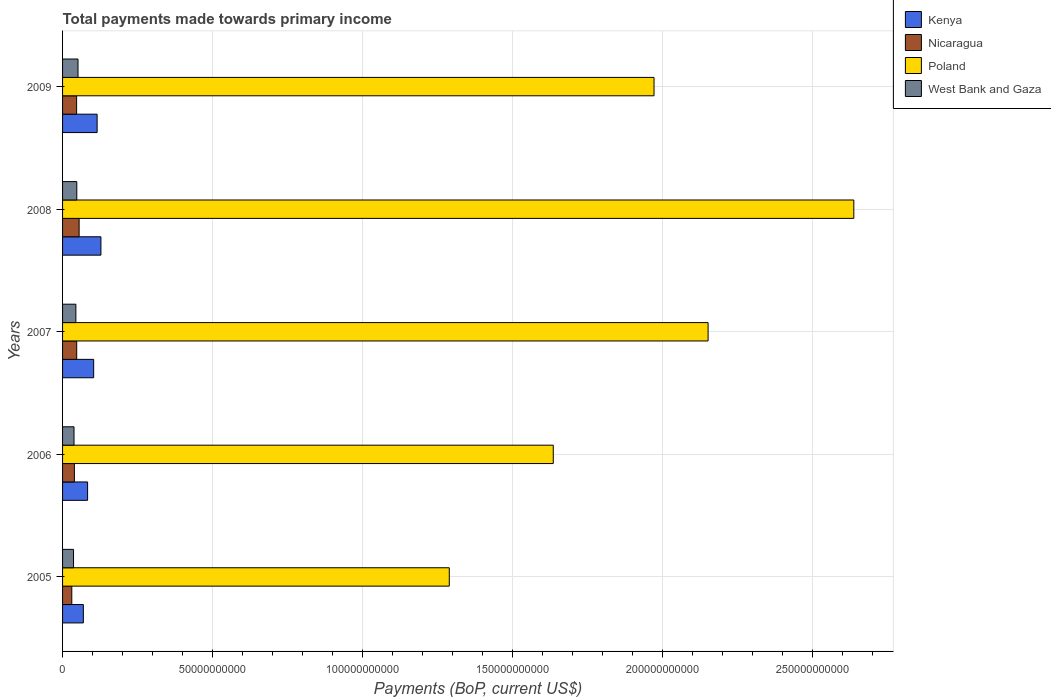How many different coloured bars are there?
Your response must be concise. 4. How many groups of bars are there?
Your response must be concise. 5. Are the number of bars on each tick of the Y-axis equal?
Keep it short and to the point. Yes. In how many cases, is the number of bars for a given year not equal to the number of legend labels?
Keep it short and to the point. 0. What is the total payments made towards primary income in Nicaragua in 2008?
Provide a succinct answer. 5.52e+09. Across all years, what is the maximum total payments made towards primary income in Poland?
Your answer should be very brief. 2.64e+11. Across all years, what is the minimum total payments made towards primary income in Kenya?
Your answer should be compact. 6.92e+09. In which year was the total payments made towards primary income in West Bank and Gaza maximum?
Ensure brevity in your answer.  2009. In which year was the total payments made towards primary income in West Bank and Gaza minimum?
Ensure brevity in your answer.  2005. What is the total total payments made towards primary income in West Bank and Gaza in the graph?
Keep it short and to the point. 2.18e+1. What is the difference between the total payments made towards primary income in West Bank and Gaza in 2007 and that in 2008?
Offer a terse response. -3.10e+08. What is the difference between the total payments made towards primary income in Kenya in 2006 and the total payments made towards primary income in Poland in 2008?
Provide a succinct answer. -2.55e+11. What is the average total payments made towards primary income in Nicaragua per year?
Your response must be concise. 4.39e+09. In the year 2009, what is the difference between the total payments made towards primary income in Kenya and total payments made towards primary income in Poland?
Your response must be concise. -1.86e+11. What is the ratio of the total payments made towards primary income in Poland in 2005 to that in 2009?
Make the answer very short. 0.65. What is the difference between the highest and the second highest total payments made towards primary income in West Bank and Gaza?
Your answer should be compact. 4.04e+08. What is the difference between the highest and the lowest total payments made towards primary income in Kenya?
Provide a short and direct response. 5.86e+09. In how many years, is the total payments made towards primary income in Nicaragua greater than the average total payments made towards primary income in Nicaragua taken over all years?
Your answer should be compact. 3. What does the 4th bar from the top in 2007 represents?
Give a very brief answer. Kenya. What does the 4th bar from the bottom in 2005 represents?
Offer a very short reply. West Bank and Gaza. Is it the case that in every year, the sum of the total payments made towards primary income in Poland and total payments made towards primary income in Nicaragua is greater than the total payments made towards primary income in West Bank and Gaza?
Make the answer very short. Yes. Are all the bars in the graph horizontal?
Give a very brief answer. Yes. Are the values on the major ticks of X-axis written in scientific E-notation?
Offer a terse response. No. Does the graph contain grids?
Your response must be concise. Yes. How many legend labels are there?
Your answer should be very brief. 4. How are the legend labels stacked?
Your answer should be very brief. Vertical. What is the title of the graph?
Offer a very short reply. Total payments made towards primary income. Does "Saudi Arabia" appear as one of the legend labels in the graph?
Ensure brevity in your answer.  No. What is the label or title of the X-axis?
Offer a very short reply. Payments (BoP, current US$). What is the Payments (BoP, current US$) of Kenya in 2005?
Your answer should be compact. 6.92e+09. What is the Payments (BoP, current US$) in Nicaragua in 2005?
Make the answer very short. 3.07e+09. What is the Payments (BoP, current US$) of Poland in 2005?
Offer a terse response. 1.29e+11. What is the Payments (BoP, current US$) of West Bank and Gaza in 2005?
Offer a terse response. 3.65e+09. What is the Payments (BoP, current US$) of Kenya in 2006?
Provide a succinct answer. 8.34e+09. What is the Payments (BoP, current US$) of Nicaragua in 2006?
Offer a terse response. 3.94e+09. What is the Payments (BoP, current US$) in Poland in 2006?
Your response must be concise. 1.63e+11. What is the Payments (BoP, current US$) of West Bank and Gaza in 2006?
Offer a very short reply. 3.81e+09. What is the Payments (BoP, current US$) of Kenya in 2007?
Provide a succinct answer. 1.04e+1. What is the Payments (BoP, current US$) of Nicaragua in 2007?
Your response must be concise. 4.71e+09. What is the Payments (BoP, current US$) in Poland in 2007?
Keep it short and to the point. 2.15e+11. What is the Payments (BoP, current US$) in West Bank and Gaza in 2007?
Keep it short and to the point. 4.43e+09. What is the Payments (BoP, current US$) of Kenya in 2008?
Offer a very short reply. 1.28e+1. What is the Payments (BoP, current US$) in Nicaragua in 2008?
Make the answer very short. 5.52e+09. What is the Payments (BoP, current US$) in Poland in 2008?
Offer a very short reply. 2.64e+11. What is the Payments (BoP, current US$) in West Bank and Gaza in 2008?
Your response must be concise. 4.74e+09. What is the Payments (BoP, current US$) in Kenya in 2009?
Your answer should be compact. 1.15e+1. What is the Payments (BoP, current US$) of Nicaragua in 2009?
Provide a short and direct response. 4.68e+09. What is the Payments (BoP, current US$) of Poland in 2009?
Offer a terse response. 1.97e+11. What is the Payments (BoP, current US$) of West Bank and Gaza in 2009?
Your answer should be very brief. 5.15e+09. Across all years, what is the maximum Payments (BoP, current US$) of Kenya?
Your response must be concise. 1.28e+1. Across all years, what is the maximum Payments (BoP, current US$) in Nicaragua?
Give a very brief answer. 5.52e+09. Across all years, what is the maximum Payments (BoP, current US$) in Poland?
Give a very brief answer. 2.64e+11. Across all years, what is the maximum Payments (BoP, current US$) of West Bank and Gaza?
Make the answer very short. 5.15e+09. Across all years, what is the minimum Payments (BoP, current US$) of Kenya?
Offer a very short reply. 6.92e+09. Across all years, what is the minimum Payments (BoP, current US$) of Nicaragua?
Provide a short and direct response. 3.07e+09. Across all years, what is the minimum Payments (BoP, current US$) of Poland?
Make the answer very short. 1.29e+11. Across all years, what is the minimum Payments (BoP, current US$) in West Bank and Gaza?
Provide a short and direct response. 3.65e+09. What is the total Payments (BoP, current US$) in Kenya in the graph?
Your response must be concise. 4.99e+1. What is the total Payments (BoP, current US$) of Nicaragua in the graph?
Make the answer very short. 2.19e+1. What is the total Payments (BoP, current US$) of Poland in the graph?
Provide a succinct answer. 9.68e+11. What is the total Payments (BoP, current US$) in West Bank and Gaza in the graph?
Your answer should be very brief. 2.18e+1. What is the difference between the Payments (BoP, current US$) in Kenya in 2005 and that in 2006?
Your answer should be very brief. -1.42e+09. What is the difference between the Payments (BoP, current US$) of Nicaragua in 2005 and that in 2006?
Give a very brief answer. -8.67e+08. What is the difference between the Payments (BoP, current US$) of Poland in 2005 and that in 2006?
Give a very brief answer. -3.46e+1. What is the difference between the Payments (BoP, current US$) of West Bank and Gaza in 2005 and that in 2006?
Make the answer very short. -1.61e+08. What is the difference between the Payments (BoP, current US$) of Kenya in 2005 and that in 2007?
Your answer should be very brief. -3.44e+09. What is the difference between the Payments (BoP, current US$) of Nicaragua in 2005 and that in 2007?
Your answer should be compact. -1.64e+09. What is the difference between the Payments (BoP, current US$) of Poland in 2005 and that in 2007?
Ensure brevity in your answer.  -8.62e+1. What is the difference between the Payments (BoP, current US$) of West Bank and Gaza in 2005 and that in 2007?
Ensure brevity in your answer.  -7.79e+08. What is the difference between the Payments (BoP, current US$) of Kenya in 2005 and that in 2008?
Provide a short and direct response. -5.86e+09. What is the difference between the Payments (BoP, current US$) of Nicaragua in 2005 and that in 2008?
Ensure brevity in your answer.  -2.44e+09. What is the difference between the Payments (BoP, current US$) of Poland in 2005 and that in 2008?
Offer a terse response. -1.35e+11. What is the difference between the Payments (BoP, current US$) in West Bank and Gaza in 2005 and that in 2008?
Make the answer very short. -1.09e+09. What is the difference between the Payments (BoP, current US$) in Kenya in 2005 and that in 2009?
Your response must be concise. -4.59e+09. What is the difference between the Payments (BoP, current US$) in Nicaragua in 2005 and that in 2009?
Ensure brevity in your answer.  -1.61e+09. What is the difference between the Payments (BoP, current US$) of Poland in 2005 and that in 2009?
Ensure brevity in your answer.  -6.82e+1. What is the difference between the Payments (BoP, current US$) of West Bank and Gaza in 2005 and that in 2009?
Offer a terse response. -1.49e+09. What is the difference between the Payments (BoP, current US$) in Kenya in 2006 and that in 2007?
Give a very brief answer. -2.02e+09. What is the difference between the Payments (BoP, current US$) of Nicaragua in 2006 and that in 2007?
Provide a succinct answer. -7.70e+08. What is the difference between the Payments (BoP, current US$) in Poland in 2006 and that in 2007?
Offer a terse response. -5.16e+1. What is the difference between the Payments (BoP, current US$) in West Bank and Gaza in 2006 and that in 2007?
Make the answer very short. -6.18e+08. What is the difference between the Payments (BoP, current US$) of Kenya in 2006 and that in 2008?
Give a very brief answer. -4.44e+09. What is the difference between the Payments (BoP, current US$) in Nicaragua in 2006 and that in 2008?
Your response must be concise. -1.58e+09. What is the difference between the Payments (BoP, current US$) of Poland in 2006 and that in 2008?
Your response must be concise. -1.00e+11. What is the difference between the Payments (BoP, current US$) in West Bank and Gaza in 2006 and that in 2008?
Your response must be concise. -9.28e+08. What is the difference between the Payments (BoP, current US$) of Kenya in 2006 and that in 2009?
Your answer should be compact. -3.17e+09. What is the difference between the Payments (BoP, current US$) in Nicaragua in 2006 and that in 2009?
Give a very brief answer. -7.39e+08. What is the difference between the Payments (BoP, current US$) in Poland in 2006 and that in 2009?
Provide a succinct answer. -3.36e+1. What is the difference between the Payments (BoP, current US$) of West Bank and Gaza in 2006 and that in 2009?
Provide a short and direct response. -1.33e+09. What is the difference between the Payments (BoP, current US$) of Kenya in 2007 and that in 2008?
Provide a succinct answer. -2.42e+09. What is the difference between the Payments (BoP, current US$) in Nicaragua in 2007 and that in 2008?
Offer a very short reply. -8.07e+08. What is the difference between the Payments (BoP, current US$) in Poland in 2007 and that in 2008?
Offer a terse response. -4.86e+1. What is the difference between the Payments (BoP, current US$) of West Bank and Gaza in 2007 and that in 2008?
Offer a terse response. -3.10e+08. What is the difference between the Payments (BoP, current US$) of Kenya in 2007 and that in 2009?
Offer a terse response. -1.15e+09. What is the difference between the Payments (BoP, current US$) of Nicaragua in 2007 and that in 2009?
Offer a terse response. 3.12e+07. What is the difference between the Payments (BoP, current US$) of Poland in 2007 and that in 2009?
Offer a very short reply. 1.80e+1. What is the difference between the Payments (BoP, current US$) of West Bank and Gaza in 2007 and that in 2009?
Provide a short and direct response. -7.14e+08. What is the difference between the Payments (BoP, current US$) in Kenya in 2008 and that in 2009?
Offer a terse response. 1.27e+09. What is the difference between the Payments (BoP, current US$) of Nicaragua in 2008 and that in 2009?
Offer a very short reply. 8.38e+08. What is the difference between the Payments (BoP, current US$) in Poland in 2008 and that in 2009?
Ensure brevity in your answer.  6.66e+1. What is the difference between the Payments (BoP, current US$) of West Bank and Gaza in 2008 and that in 2009?
Your answer should be compact. -4.04e+08. What is the difference between the Payments (BoP, current US$) in Kenya in 2005 and the Payments (BoP, current US$) in Nicaragua in 2006?
Ensure brevity in your answer.  2.98e+09. What is the difference between the Payments (BoP, current US$) in Kenya in 2005 and the Payments (BoP, current US$) in Poland in 2006?
Your answer should be very brief. -1.57e+11. What is the difference between the Payments (BoP, current US$) in Kenya in 2005 and the Payments (BoP, current US$) in West Bank and Gaza in 2006?
Your answer should be very brief. 3.11e+09. What is the difference between the Payments (BoP, current US$) in Nicaragua in 2005 and the Payments (BoP, current US$) in Poland in 2006?
Your answer should be very brief. -1.60e+11. What is the difference between the Payments (BoP, current US$) of Nicaragua in 2005 and the Payments (BoP, current US$) of West Bank and Gaza in 2006?
Give a very brief answer. -7.39e+08. What is the difference between the Payments (BoP, current US$) of Poland in 2005 and the Payments (BoP, current US$) of West Bank and Gaza in 2006?
Provide a succinct answer. 1.25e+11. What is the difference between the Payments (BoP, current US$) in Kenya in 2005 and the Payments (BoP, current US$) in Nicaragua in 2007?
Offer a terse response. 2.21e+09. What is the difference between the Payments (BoP, current US$) of Kenya in 2005 and the Payments (BoP, current US$) of Poland in 2007?
Your answer should be very brief. -2.08e+11. What is the difference between the Payments (BoP, current US$) of Kenya in 2005 and the Payments (BoP, current US$) of West Bank and Gaza in 2007?
Provide a succinct answer. 2.49e+09. What is the difference between the Payments (BoP, current US$) in Nicaragua in 2005 and the Payments (BoP, current US$) in Poland in 2007?
Provide a succinct answer. -2.12e+11. What is the difference between the Payments (BoP, current US$) in Nicaragua in 2005 and the Payments (BoP, current US$) in West Bank and Gaza in 2007?
Provide a succinct answer. -1.36e+09. What is the difference between the Payments (BoP, current US$) of Poland in 2005 and the Payments (BoP, current US$) of West Bank and Gaza in 2007?
Your response must be concise. 1.24e+11. What is the difference between the Payments (BoP, current US$) in Kenya in 2005 and the Payments (BoP, current US$) in Nicaragua in 2008?
Keep it short and to the point. 1.40e+09. What is the difference between the Payments (BoP, current US$) in Kenya in 2005 and the Payments (BoP, current US$) in Poland in 2008?
Provide a short and direct response. -2.57e+11. What is the difference between the Payments (BoP, current US$) in Kenya in 2005 and the Payments (BoP, current US$) in West Bank and Gaza in 2008?
Offer a terse response. 2.18e+09. What is the difference between the Payments (BoP, current US$) in Nicaragua in 2005 and the Payments (BoP, current US$) in Poland in 2008?
Provide a succinct answer. -2.61e+11. What is the difference between the Payments (BoP, current US$) in Nicaragua in 2005 and the Payments (BoP, current US$) in West Bank and Gaza in 2008?
Your answer should be compact. -1.67e+09. What is the difference between the Payments (BoP, current US$) of Poland in 2005 and the Payments (BoP, current US$) of West Bank and Gaza in 2008?
Your answer should be very brief. 1.24e+11. What is the difference between the Payments (BoP, current US$) of Kenya in 2005 and the Payments (BoP, current US$) of Nicaragua in 2009?
Make the answer very short. 2.24e+09. What is the difference between the Payments (BoP, current US$) of Kenya in 2005 and the Payments (BoP, current US$) of Poland in 2009?
Keep it short and to the point. -1.90e+11. What is the difference between the Payments (BoP, current US$) of Kenya in 2005 and the Payments (BoP, current US$) of West Bank and Gaza in 2009?
Ensure brevity in your answer.  1.77e+09. What is the difference between the Payments (BoP, current US$) in Nicaragua in 2005 and the Payments (BoP, current US$) in Poland in 2009?
Offer a terse response. -1.94e+11. What is the difference between the Payments (BoP, current US$) in Nicaragua in 2005 and the Payments (BoP, current US$) in West Bank and Gaza in 2009?
Your response must be concise. -2.07e+09. What is the difference between the Payments (BoP, current US$) in Poland in 2005 and the Payments (BoP, current US$) in West Bank and Gaza in 2009?
Your answer should be compact. 1.24e+11. What is the difference between the Payments (BoP, current US$) of Kenya in 2006 and the Payments (BoP, current US$) of Nicaragua in 2007?
Provide a succinct answer. 3.63e+09. What is the difference between the Payments (BoP, current US$) of Kenya in 2006 and the Payments (BoP, current US$) of Poland in 2007?
Offer a very short reply. -2.07e+11. What is the difference between the Payments (BoP, current US$) of Kenya in 2006 and the Payments (BoP, current US$) of West Bank and Gaza in 2007?
Keep it short and to the point. 3.91e+09. What is the difference between the Payments (BoP, current US$) of Nicaragua in 2006 and the Payments (BoP, current US$) of Poland in 2007?
Ensure brevity in your answer.  -2.11e+11. What is the difference between the Payments (BoP, current US$) of Nicaragua in 2006 and the Payments (BoP, current US$) of West Bank and Gaza in 2007?
Offer a very short reply. -4.90e+08. What is the difference between the Payments (BoP, current US$) of Poland in 2006 and the Payments (BoP, current US$) of West Bank and Gaza in 2007?
Provide a succinct answer. 1.59e+11. What is the difference between the Payments (BoP, current US$) in Kenya in 2006 and the Payments (BoP, current US$) in Nicaragua in 2008?
Ensure brevity in your answer.  2.82e+09. What is the difference between the Payments (BoP, current US$) of Kenya in 2006 and the Payments (BoP, current US$) of Poland in 2008?
Provide a short and direct response. -2.55e+11. What is the difference between the Payments (BoP, current US$) of Kenya in 2006 and the Payments (BoP, current US$) of West Bank and Gaza in 2008?
Your answer should be very brief. 3.60e+09. What is the difference between the Payments (BoP, current US$) of Nicaragua in 2006 and the Payments (BoP, current US$) of Poland in 2008?
Your response must be concise. -2.60e+11. What is the difference between the Payments (BoP, current US$) of Nicaragua in 2006 and the Payments (BoP, current US$) of West Bank and Gaza in 2008?
Your answer should be compact. -8.00e+08. What is the difference between the Payments (BoP, current US$) in Poland in 2006 and the Payments (BoP, current US$) in West Bank and Gaza in 2008?
Provide a succinct answer. 1.59e+11. What is the difference between the Payments (BoP, current US$) of Kenya in 2006 and the Payments (BoP, current US$) of Nicaragua in 2009?
Provide a succinct answer. 3.66e+09. What is the difference between the Payments (BoP, current US$) of Kenya in 2006 and the Payments (BoP, current US$) of Poland in 2009?
Offer a very short reply. -1.89e+11. What is the difference between the Payments (BoP, current US$) of Kenya in 2006 and the Payments (BoP, current US$) of West Bank and Gaza in 2009?
Your response must be concise. 3.19e+09. What is the difference between the Payments (BoP, current US$) in Nicaragua in 2006 and the Payments (BoP, current US$) in Poland in 2009?
Give a very brief answer. -1.93e+11. What is the difference between the Payments (BoP, current US$) of Nicaragua in 2006 and the Payments (BoP, current US$) of West Bank and Gaza in 2009?
Your answer should be compact. -1.20e+09. What is the difference between the Payments (BoP, current US$) in Poland in 2006 and the Payments (BoP, current US$) in West Bank and Gaza in 2009?
Ensure brevity in your answer.  1.58e+11. What is the difference between the Payments (BoP, current US$) in Kenya in 2007 and the Payments (BoP, current US$) in Nicaragua in 2008?
Make the answer very short. 4.84e+09. What is the difference between the Payments (BoP, current US$) in Kenya in 2007 and the Payments (BoP, current US$) in Poland in 2008?
Offer a very short reply. -2.53e+11. What is the difference between the Payments (BoP, current US$) in Kenya in 2007 and the Payments (BoP, current US$) in West Bank and Gaza in 2008?
Your answer should be compact. 5.62e+09. What is the difference between the Payments (BoP, current US$) in Nicaragua in 2007 and the Payments (BoP, current US$) in Poland in 2008?
Offer a terse response. -2.59e+11. What is the difference between the Payments (BoP, current US$) in Nicaragua in 2007 and the Payments (BoP, current US$) in West Bank and Gaza in 2008?
Keep it short and to the point. -3.05e+07. What is the difference between the Payments (BoP, current US$) in Poland in 2007 and the Payments (BoP, current US$) in West Bank and Gaza in 2008?
Your answer should be very brief. 2.10e+11. What is the difference between the Payments (BoP, current US$) of Kenya in 2007 and the Payments (BoP, current US$) of Nicaragua in 2009?
Make the answer very short. 5.68e+09. What is the difference between the Payments (BoP, current US$) in Kenya in 2007 and the Payments (BoP, current US$) in Poland in 2009?
Your response must be concise. -1.87e+11. What is the difference between the Payments (BoP, current US$) in Kenya in 2007 and the Payments (BoP, current US$) in West Bank and Gaza in 2009?
Your response must be concise. 5.22e+09. What is the difference between the Payments (BoP, current US$) in Nicaragua in 2007 and the Payments (BoP, current US$) in Poland in 2009?
Give a very brief answer. -1.92e+11. What is the difference between the Payments (BoP, current US$) in Nicaragua in 2007 and the Payments (BoP, current US$) in West Bank and Gaza in 2009?
Provide a succinct answer. -4.34e+08. What is the difference between the Payments (BoP, current US$) of Poland in 2007 and the Payments (BoP, current US$) of West Bank and Gaza in 2009?
Offer a very short reply. 2.10e+11. What is the difference between the Payments (BoP, current US$) of Kenya in 2008 and the Payments (BoP, current US$) of Nicaragua in 2009?
Ensure brevity in your answer.  8.10e+09. What is the difference between the Payments (BoP, current US$) of Kenya in 2008 and the Payments (BoP, current US$) of Poland in 2009?
Ensure brevity in your answer.  -1.84e+11. What is the difference between the Payments (BoP, current US$) of Kenya in 2008 and the Payments (BoP, current US$) of West Bank and Gaza in 2009?
Provide a succinct answer. 7.63e+09. What is the difference between the Payments (BoP, current US$) of Nicaragua in 2008 and the Payments (BoP, current US$) of Poland in 2009?
Offer a very short reply. -1.92e+11. What is the difference between the Payments (BoP, current US$) in Nicaragua in 2008 and the Payments (BoP, current US$) in West Bank and Gaza in 2009?
Your answer should be compact. 3.73e+08. What is the difference between the Payments (BoP, current US$) in Poland in 2008 and the Payments (BoP, current US$) in West Bank and Gaza in 2009?
Your response must be concise. 2.58e+11. What is the average Payments (BoP, current US$) in Kenya per year?
Keep it short and to the point. 9.98e+09. What is the average Payments (BoP, current US$) of Nicaragua per year?
Ensure brevity in your answer.  4.39e+09. What is the average Payments (BoP, current US$) of Poland per year?
Your response must be concise. 1.94e+11. What is the average Payments (BoP, current US$) of West Bank and Gaza per year?
Make the answer very short. 4.36e+09. In the year 2005, what is the difference between the Payments (BoP, current US$) in Kenya and Payments (BoP, current US$) in Nicaragua?
Your answer should be very brief. 3.85e+09. In the year 2005, what is the difference between the Payments (BoP, current US$) in Kenya and Payments (BoP, current US$) in Poland?
Provide a succinct answer. -1.22e+11. In the year 2005, what is the difference between the Payments (BoP, current US$) in Kenya and Payments (BoP, current US$) in West Bank and Gaza?
Your answer should be compact. 3.27e+09. In the year 2005, what is the difference between the Payments (BoP, current US$) in Nicaragua and Payments (BoP, current US$) in Poland?
Ensure brevity in your answer.  -1.26e+11. In the year 2005, what is the difference between the Payments (BoP, current US$) of Nicaragua and Payments (BoP, current US$) of West Bank and Gaza?
Provide a short and direct response. -5.79e+08. In the year 2005, what is the difference between the Payments (BoP, current US$) of Poland and Payments (BoP, current US$) of West Bank and Gaza?
Provide a short and direct response. 1.25e+11. In the year 2006, what is the difference between the Payments (BoP, current US$) in Kenya and Payments (BoP, current US$) in Nicaragua?
Your answer should be very brief. 4.40e+09. In the year 2006, what is the difference between the Payments (BoP, current US$) of Kenya and Payments (BoP, current US$) of Poland?
Provide a succinct answer. -1.55e+11. In the year 2006, what is the difference between the Payments (BoP, current US$) in Kenya and Payments (BoP, current US$) in West Bank and Gaza?
Provide a short and direct response. 4.53e+09. In the year 2006, what is the difference between the Payments (BoP, current US$) in Nicaragua and Payments (BoP, current US$) in Poland?
Offer a very short reply. -1.60e+11. In the year 2006, what is the difference between the Payments (BoP, current US$) in Nicaragua and Payments (BoP, current US$) in West Bank and Gaza?
Give a very brief answer. 1.28e+08. In the year 2006, what is the difference between the Payments (BoP, current US$) in Poland and Payments (BoP, current US$) in West Bank and Gaza?
Your answer should be compact. 1.60e+11. In the year 2007, what is the difference between the Payments (BoP, current US$) of Kenya and Payments (BoP, current US$) of Nicaragua?
Provide a short and direct response. 5.65e+09. In the year 2007, what is the difference between the Payments (BoP, current US$) of Kenya and Payments (BoP, current US$) of Poland?
Your answer should be very brief. -2.05e+11. In the year 2007, what is the difference between the Payments (BoP, current US$) in Kenya and Payments (BoP, current US$) in West Bank and Gaza?
Make the answer very short. 5.93e+09. In the year 2007, what is the difference between the Payments (BoP, current US$) in Nicaragua and Payments (BoP, current US$) in Poland?
Offer a terse response. -2.10e+11. In the year 2007, what is the difference between the Payments (BoP, current US$) in Nicaragua and Payments (BoP, current US$) in West Bank and Gaza?
Your response must be concise. 2.80e+08. In the year 2007, what is the difference between the Payments (BoP, current US$) of Poland and Payments (BoP, current US$) of West Bank and Gaza?
Give a very brief answer. 2.11e+11. In the year 2008, what is the difference between the Payments (BoP, current US$) in Kenya and Payments (BoP, current US$) in Nicaragua?
Your answer should be very brief. 7.26e+09. In the year 2008, what is the difference between the Payments (BoP, current US$) of Kenya and Payments (BoP, current US$) of Poland?
Give a very brief answer. -2.51e+11. In the year 2008, what is the difference between the Payments (BoP, current US$) in Kenya and Payments (BoP, current US$) in West Bank and Gaza?
Your answer should be compact. 8.04e+09. In the year 2008, what is the difference between the Payments (BoP, current US$) of Nicaragua and Payments (BoP, current US$) of Poland?
Your answer should be very brief. -2.58e+11. In the year 2008, what is the difference between the Payments (BoP, current US$) in Nicaragua and Payments (BoP, current US$) in West Bank and Gaza?
Ensure brevity in your answer.  7.77e+08. In the year 2008, what is the difference between the Payments (BoP, current US$) of Poland and Payments (BoP, current US$) of West Bank and Gaza?
Ensure brevity in your answer.  2.59e+11. In the year 2009, what is the difference between the Payments (BoP, current US$) of Kenya and Payments (BoP, current US$) of Nicaragua?
Keep it short and to the point. 6.83e+09. In the year 2009, what is the difference between the Payments (BoP, current US$) in Kenya and Payments (BoP, current US$) in Poland?
Ensure brevity in your answer.  -1.86e+11. In the year 2009, what is the difference between the Payments (BoP, current US$) of Kenya and Payments (BoP, current US$) of West Bank and Gaza?
Provide a short and direct response. 6.37e+09. In the year 2009, what is the difference between the Payments (BoP, current US$) of Nicaragua and Payments (BoP, current US$) of Poland?
Make the answer very short. -1.92e+11. In the year 2009, what is the difference between the Payments (BoP, current US$) of Nicaragua and Payments (BoP, current US$) of West Bank and Gaza?
Keep it short and to the point. -4.66e+08. In the year 2009, what is the difference between the Payments (BoP, current US$) in Poland and Payments (BoP, current US$) in West Bank and Gaza?
Offer a very short reply. 1.92e+11. What is the ratio of the Payments (BoP, current US$) of Kenya in 2005 to that in 2006?
Provide a short and direct response. 0.83. What is the ratio of the Payments (BoP, current US$) in Nicaragua in 2005 to that in 2006?
Offer a terse response. 0.78. What is the ratio of the Payments (BoP, current US$) of Poland in 2005 to that in 2006?
Ensure brevity in your answer.  0.79. What is the ratio of the Payments (BoP, current US$) in West Bank and Gaza in 2005 to that in 2006?
Your answer should be compact. 0.96. What is the ratio of the Payments (BoP, current US$) of Kenya in 2005 to that in 2007?
Give a very brief answer. 0.67. What is the ratio of the Payments (BoP, current US$) in Nicaragua in 2005 to that in 2007?
Ensure brevity in your answer.  0.65. What is the ratio of the Payments (BoP, current US$) of Poland in 2005 to that in 2007?
Offer a terse response. 0.6. What is the ratio of the Payments (BoP, current US$) of West Bank and Gaza in 2005 to that in 2007?
Give a very brief answer. 0.82. What is the ratio of the Payments (BoP, current US$) of Kenya in 2005 to that in 2008?
Offer a very short reply. 0.54. What is the ratio of the Payments (BoP, current US$) of Nicaragua in 2005 to that in 2008?
Your answer should be very brief. 0.56. What is the ratio of the Payments (BoP, current US$) of Poland in 2005 to that in 2008?
Your response must be concise. 0.49. What is the ratio of the Payments (BoP, current US$) of West Bank and Gaza in 2005 to that in 2008?
Your answer should be very brief. 0.77. What is the ratio of the Payments (BoP, current US$) in Kenya in 2005 to that in 2009?
Offer a very short reply. 0.6. What is the ratio of the Payments (BoP, current US$) in Nicaragua in 2005 to that in 2009?
Make the answer very short. 0.66. What is the ratio of the Payments (BoP, current US$) in Poland in 2005 to that in 2009?
Offer a very short reply. 0.65. What is the ratio of the Payments (BoP, current US$) in West Bank and Gaza in 2005 to that in 2009?
Provide a short and direct response. 0.71. What is the ratio of the Payments (BoP, current US$) of Kenya in 2006 to that in 2007?
Your response must be concise. 0.8. What is the ratio of the Payments (BoP, current US$) in Nicaragua in 2006 to that in 2007?
Provide a short and direct response. 0.84. What is the ratio of the Payments (BoP, current US$) in Poland in 2006 to that in 2007?
Your response must be concise. 0.76. What is the ratio of the Payments (BoP, current US$) in West Bank and Gaza in 2006 to that in 2007?
Keep it short and to the point. 0.86. What is the ratio of the Payments (BoP, current US$) of Kenya in 2006 to that in 2008?
Give a very brief answer. 0.65. What is the ratio of the Payments (BoP, current US$) of Nicaragua in 2006 to that in 2008?
Keep it short and to the point. 0.71. What is the ratio of the Payments (BoP, current US$) of Poland in 2006 to that in 2008?
Make the answer very short. 0.62. What is the ratio of the Payments (BoP, current US$) of West Bank and Gaza in 2006 to that in 2008?
Provide a short and direct response. 0.8. What is the ratio of the Payments (BoP, current US$) of Kenya in 2006 to that in 2009?
Provide a succinct answer. 0.72. What is the ratio of the Payments (BoP, current US$) of Nicaragua in 2006 to that in 2009?
Your answer should be compact. 0.84. What is the ratio of the Payments (BoP, current US$) in Poland in 2006 to that in 2009?
Your response must be concise. 0.83. What is the ratio of the Payments (BoP, current US$) in West Bank and Gaza in 2006 to that in 2009?
Offer a terse response. 0.74. What is the ratio of the Payments (BoP, current US$) of Kenya in 2007 to that in 2008?
Keep it short and to the point. 0.81. What is the ratio of the Payments (BoP, current US$) in Nicaragua in 2007 to that in 2008?
Provide a succinct answer. 0.85. What is the ratio of the Payments (BoP, current US$) of Poland in 2007 to that in 2008?
Provide a short and direct response. 0.82. What is the ratio of the Payments (BoP, current US$) in West Bank and Gaza in 2007 to that in 2008?
Keep it short and to the point. 0.93. What is the ratio of the Payments (BoP, current US$) of Kenya in 2007 to that in 2009?
Your answer should be compact. 0.9. What is the ratio of the Payments (BoP, current US$) in Nicaragua in 2007 to that in 2009?
Provide a short and direct response. 1.01. What is the ratio of the Payments (BoP, current US$) of Poland in 2007 to that in 2009?
Ensure brevity in your answer.  1.09. What is the ratio of the Payments (BoP, current US$) of West Bank and Gaza in 2007 to that in 2009?
Your response must be concise. 0.86. What is the ratio of the Payments (BoP, current US$) in Kenya in 2008 to that in 2009?
Provide a succinct answer. 1.11. What is the ratio of the Payments (BoP, current US$) of Nicaragua in 2008 to that in 2009?
Your answer should be compact. 1.18. What is the ratio of the Payments (BoP, current US$) in Poland in 2008 to that in 2009?
Your answer should be compact. 1.34. What is the ratio of the Payments (BoP, current US$) in West Bank and Gaza in 2008 to that in 2009?
Your response must be concise. 0.92. What is the difference between the highest and the second highest Payments (BoP, current US$) of Kenya?
Provide a short and direct response. 1.27e+09. What is the difference between the highest and the second highest Payments (BoP, current US$) of Nicaragua?
Give a very brief answer. 8.07e+08. What is the difference between the highest and the second highest Payments (BoP, current US$) in Poland?
Offer a very short reply. 4.86e+1. What is the difference between the highest and the second highest Payments (BoP, current US$) of West Bank and Gaza?
Offer a very short reply. 4.04e+08. What is the difference between the highest and the lowest Payments (BoP, current US$) in Kenya?
Offer a terse response. 5.86e+09. What is the difference between the highest and the lowest Payments (BoP, current US$) of Nicaragua?
Offer a terse response. 2.44e+09. What is the difference between the highest and the lowest Payments (BoP, current US$) of Poland?
Give a very brief answer. 1.35e+11. What is the difference between the highest and the lowest Payments (BoP, current US$) of West Bank and Gaza?
Your answer should be compact. 1.49e+09. 